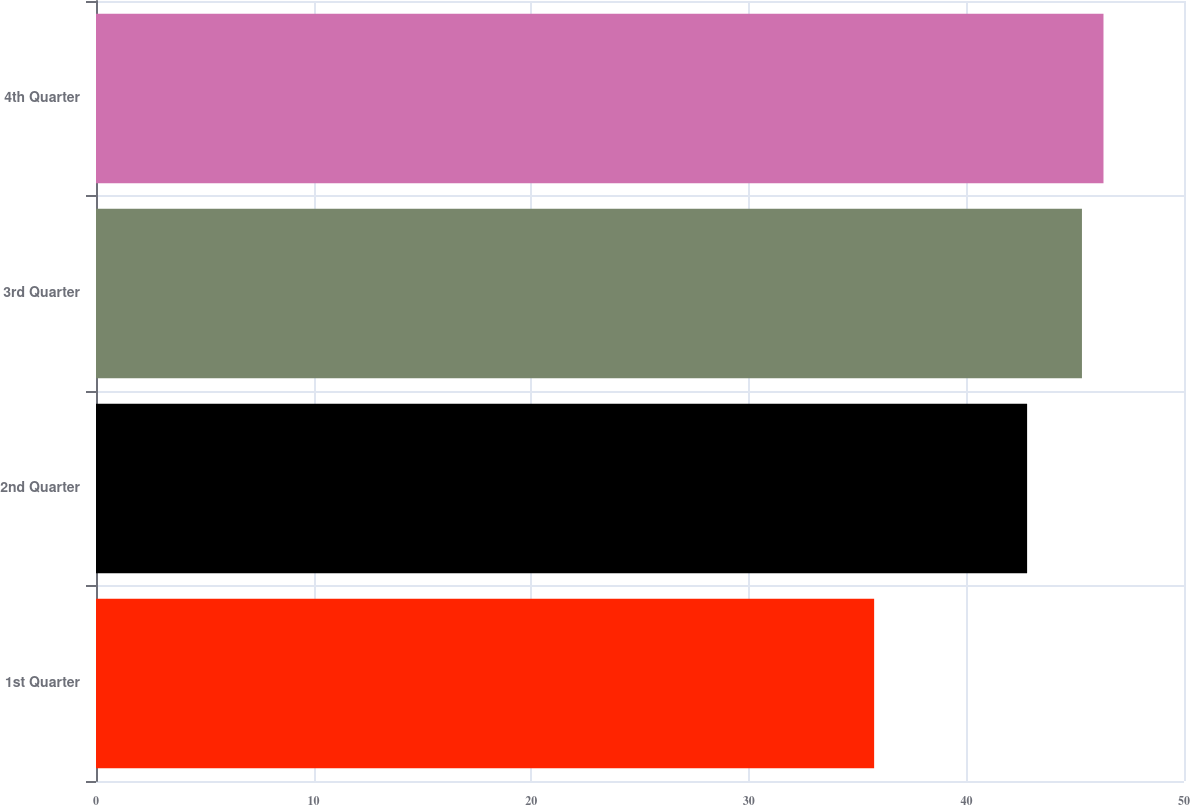Convert chart to OTSL. <chart><loc_0><loc_0><loc_500><loc_500><bar_chart><fcel>1st Quarter<fcel>2nd Quarter<fcel>3rd Quarter<fcel>4th Quarter<nl><fcel>35.76<fcel>42.79<fcel>45.31<fcel>46.3<nl></chart> 